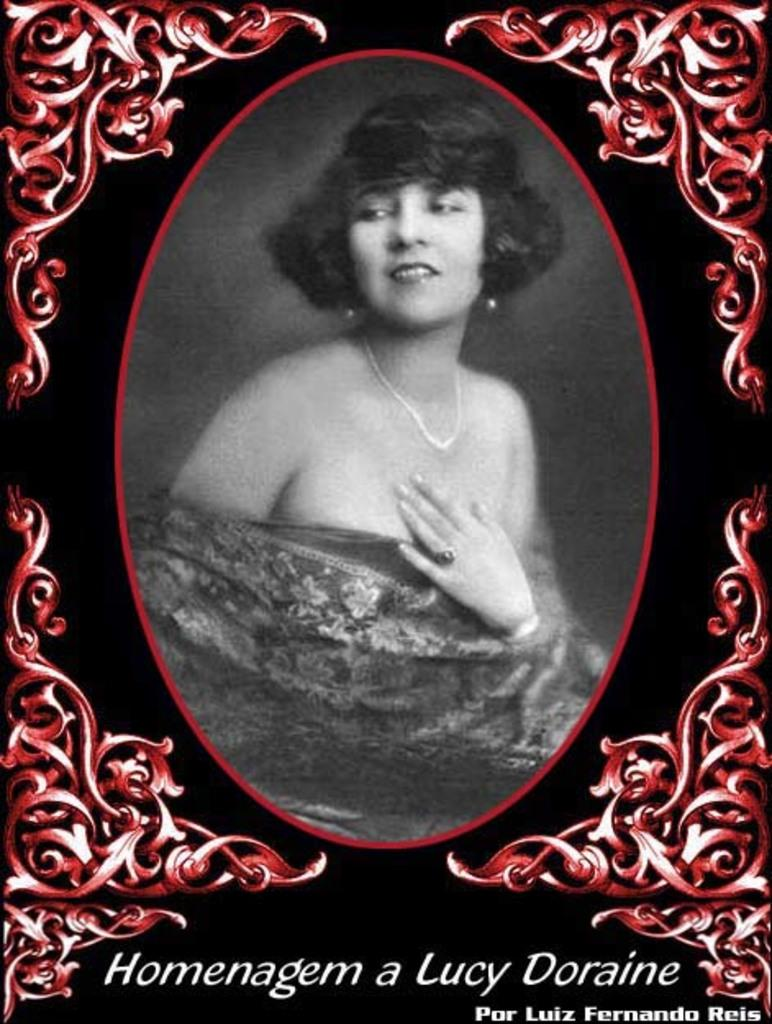Who is the main subject in the image? There is a woman in the image. Can you describe any characteristics of the image? The image appears to be edited. What additional information is provided at the bottom of the image? There is text written at the bottom of the image. What type of meal is the woman preparing in the image? There is no meal preparation visible in the image; it only shows a woman. Can you tell me who the father of the woman is in the image? There is no information about the woman's father in the image. 